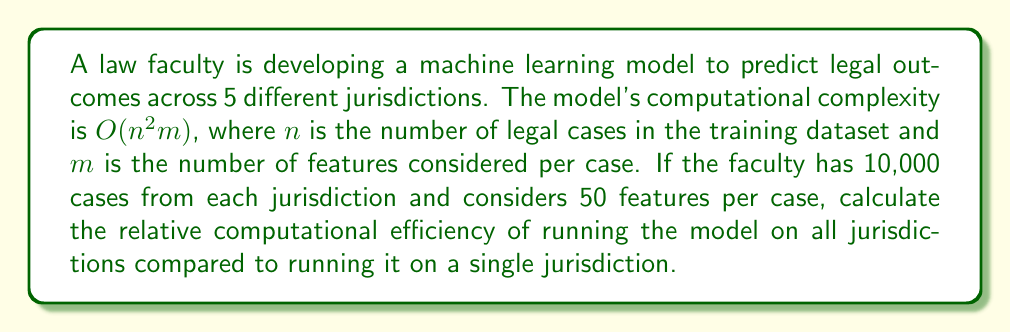Solve this math problem. To solve this problem, we need to follow these steps:

1. Calculate the computational complexity for a single jurisdiction:
   Let $n_1 = 10,000$ (cases in one jurisdiction)
   $m = 50$ (features per case)
   Complexity for one jurisdiction: $O(n_1^2m) = O(10000^2 \times 50) = O(5 \times 10^9)$

2. Calculate the computational complexity for all five jurisdictions:
   Total cases: $n_{total} = 5 \times 10,000 = 50,000$
   Complexity for all jurisdictions: $O(n_{total}^2m) = O(50000^2 \times 50) = O(1.25 \times 10^{11})$

3. Calculate the relative efficiency:
   Relative efficiency = $\frac{\text{Complexity for all jurisdictions}}{\text{Complexity for one jurisdiction}}$
   
   $= \frac{O(1.25 \times 10^{11})}{O(5 \times 10^9)} = \frac{1.25 \times 10^{11}}{5 \times 10^9} = 25$

This means that running the model on all jurisdictions is 25 times more computationally intensive than running it on a single jurisdiction.
Answer: The relative computational efficiency of running the model on all 5 jurisdictions compared to a single jurisdiction is 25:1, meaning it is 25 times more computationally intensive. 